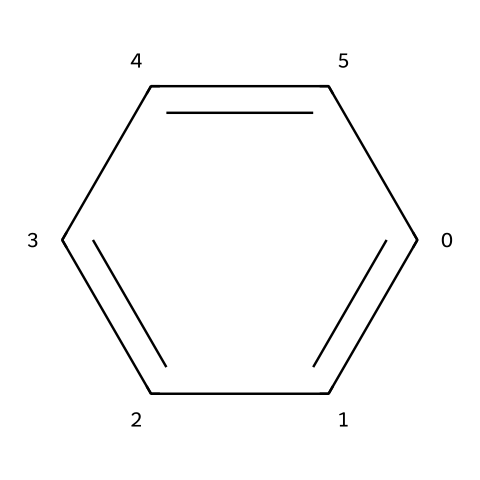What is the molecular formula of the chemical represented by this structure? The structure of benzene indicates it is made up of six carbon atoms (C) and six hydrogen atoms (H), giving it the molecular formula C6H6.
Answer: C6H6 How many double bonds are present in the chemical structure? Benzene has alternating single and double bonds in its ring structure; however, due to resonance, it is often represented as having three double bonds because all bonds are equivalent and delocalized.
Answer: 3 What is the degree of unsaturation in this chemical? Benzene is a cyclic compound with double bonds, which contribute to its degree of unsaturation; it has a degree of unsaturation of 4, calculated by the formula (2C + 2 - H) / 2, where C is 6 and H is 6.
Answer: 4 What type of chemical bonding predominates in this structure? The chemical structure exhibits covalent bonding between carbon and hydrogen atoms, and carbon-carbon bonds are also covalent with delocalized π electrons contributing to bonding.
Answer: Covalent Is this chemical classified as a carcinogen? Benzene is recognized as a carcinogen and has been extensively studied for its health risks, including the potential to cause cancer.
Answer: Yes 